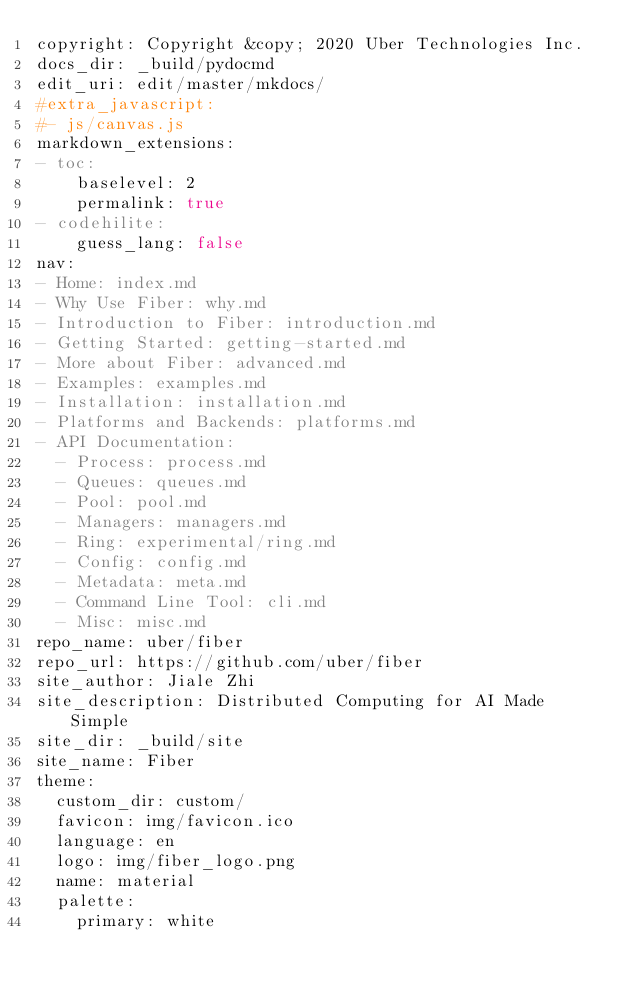Convert code to text. <code><loc_0><loc_0><loc_500><loc_500><_YAML_>copyright: Copyright &copy; 2020 Uber Technologies Inc.
docs_dir: _build/pydocmd
edit_uri: edit/master/mkdocs/
#extra_javascript:
#- js/canvas.js
markdown_extensions:
- toc:
    baselevel: 2
    permalink: true
- codehilite:
    guess_lang: false
nav:
- Home: index.md
- Why Use Fiber: why.md
- Introduction to Fiber: introduction.md
- Getting Started: getting-started.md
- More about Fiber: advanced.md
- Examples: examples.md
- Installation: installation.md
- Platforms and Backends: platforms.md
- API Documentation:
  - Process: process.md
  - Queues: queues.md
  - Pool: pool.md
  - Managers: managers.md
  - Ring: experimental/ring.md
  - Config: config.md
  - Metadata: meta.md
  - Command Line Tool: cli.md
  - Misc: misc.md
repo_name: uber/fiber
repo_url: https://github.com/uber/fiber
site_author: Jiale Zhi
site_description: Distributed Computing for AI Made Simple
site_dir: _build/site
site_name: Fiber
theme:
  custom_dir: custom/
  favicon: img/favicon.ico
  language: en
  logo: img/fiber_logo.png
  name: material
  palette:
    primary: white
</code> 